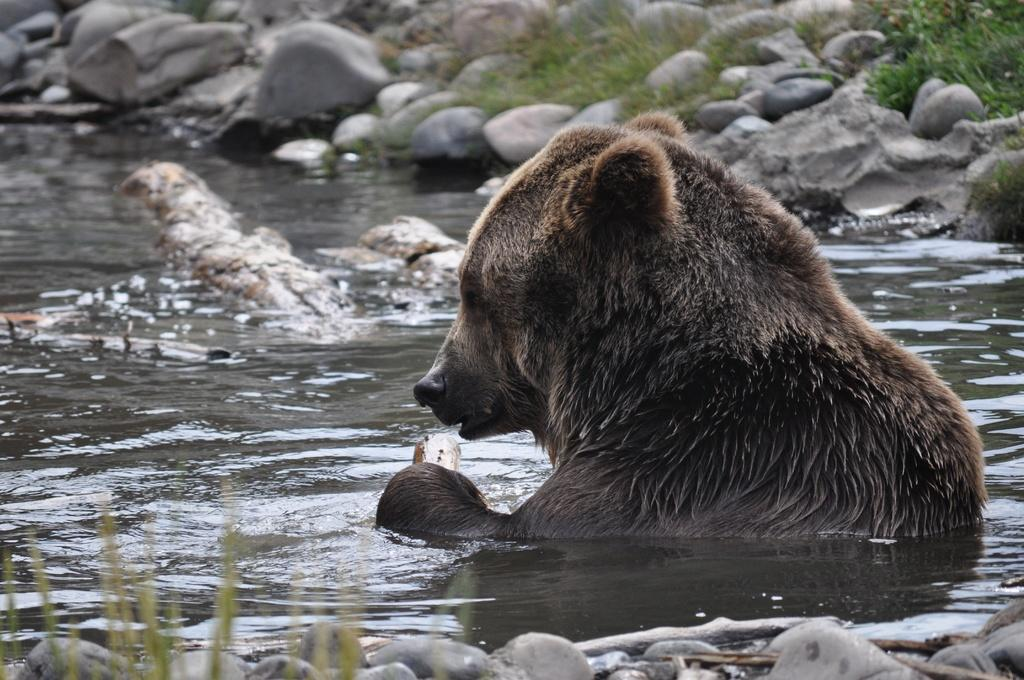What type of animal can be seen in the image? There is an animal in the image, but we cannot determine the specific type without more information. What is located at the bottom of the image? There is water visible at the bottom of the image. What other natural elements are present in the image? There are rocks and grass in the image. What type of haircut does the animal have in the image? There is no information about the animal's haircut in the image. How many potatoes can be seen in the image? There are no potatoes present in the image. 